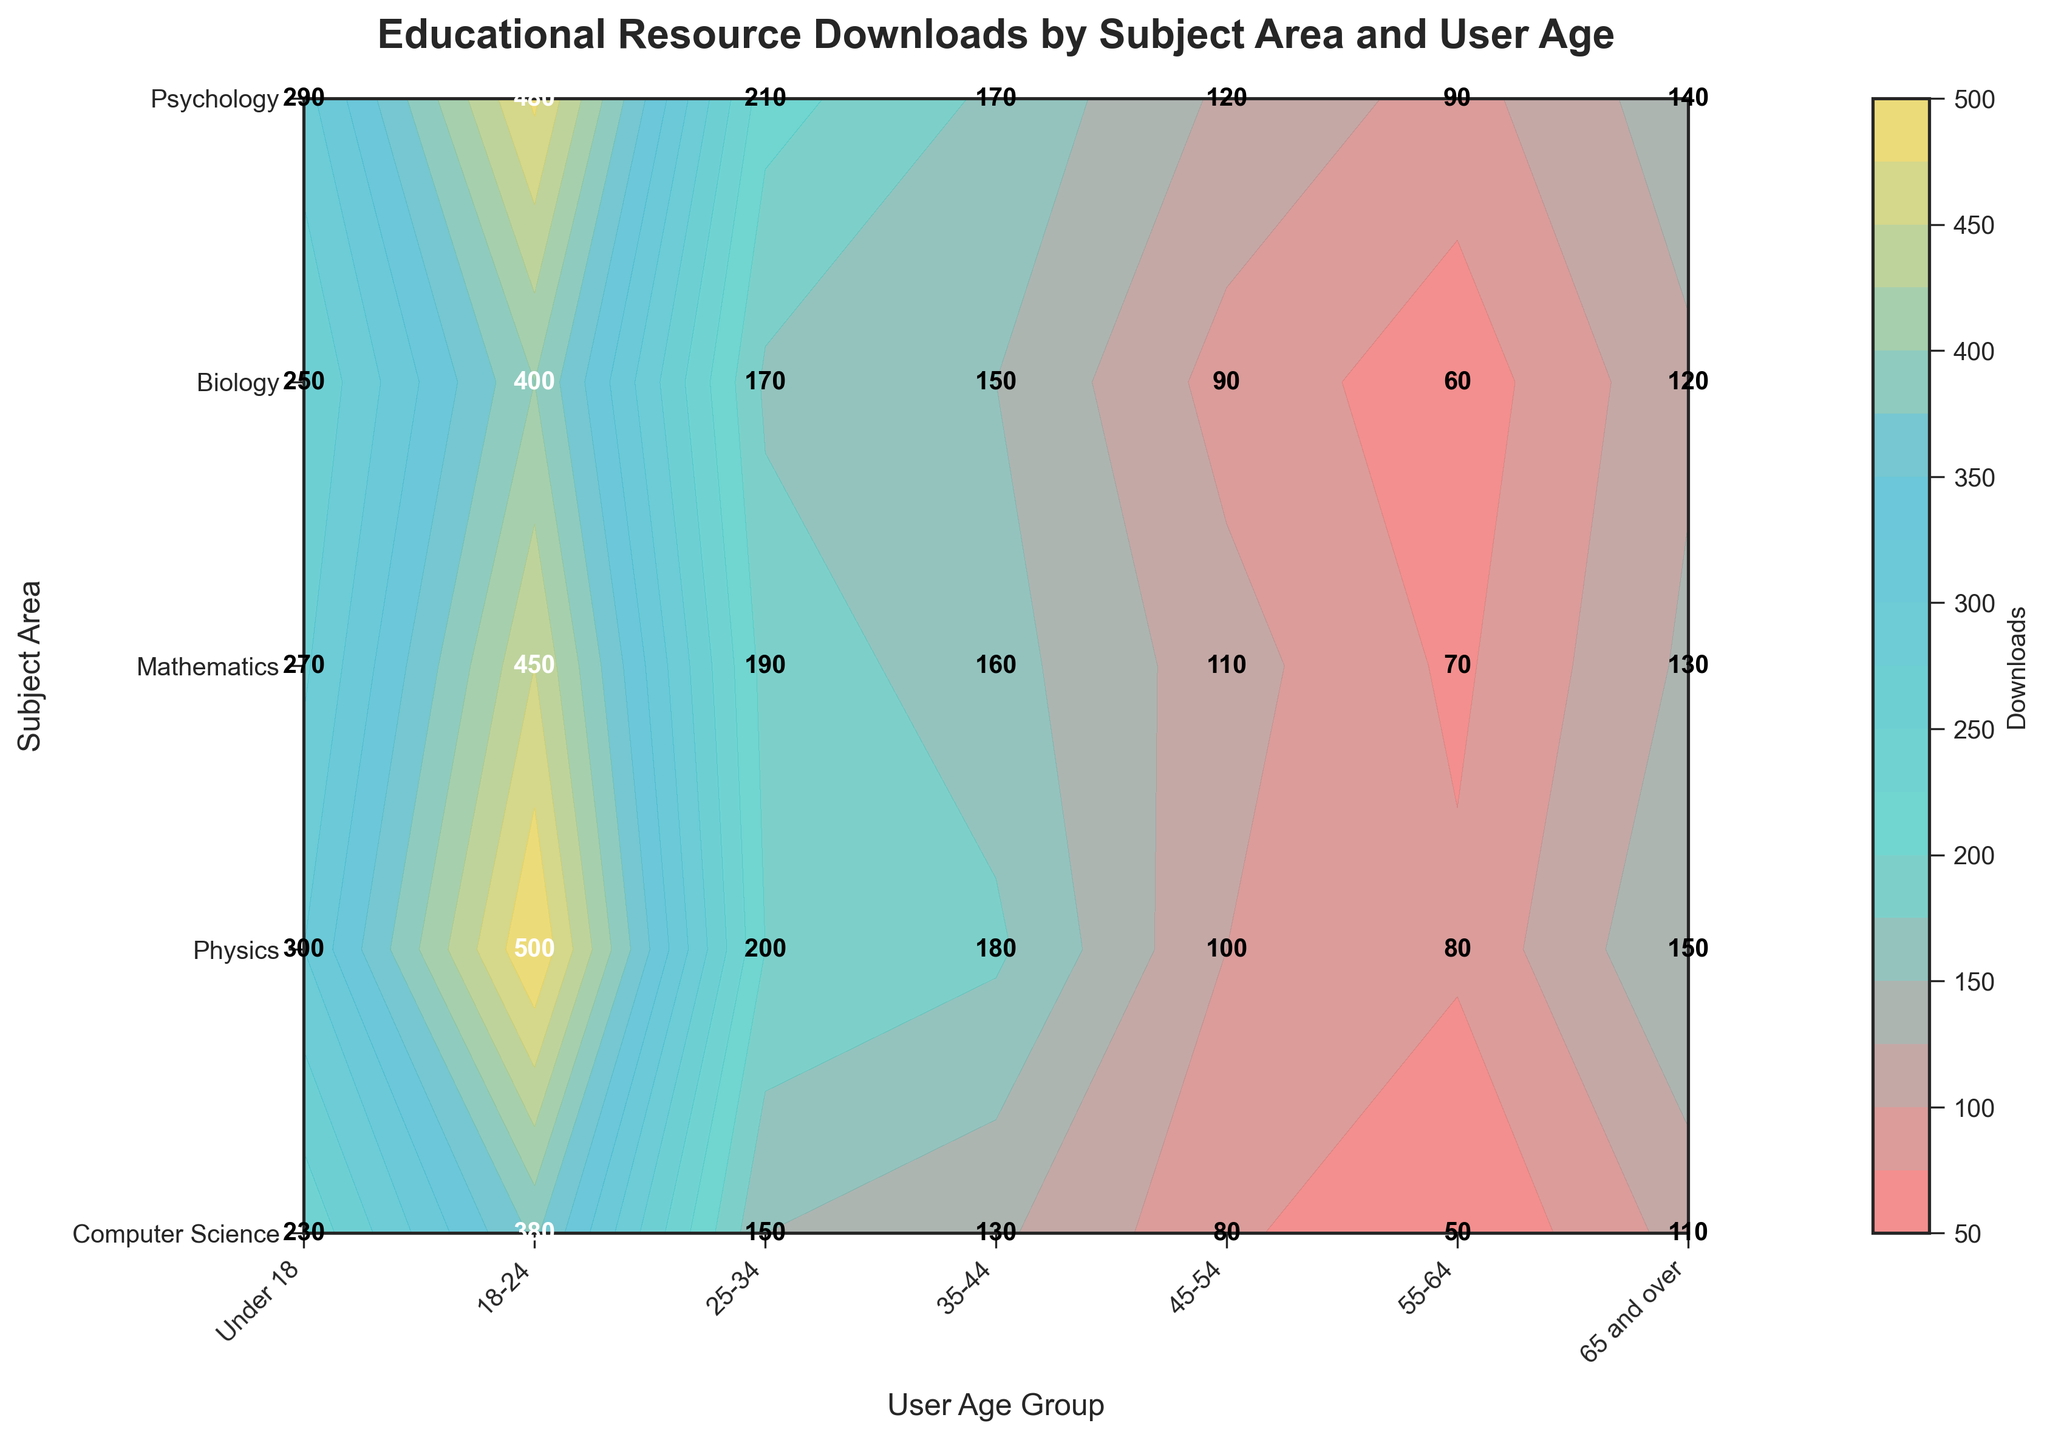What is the title of the plot? The title of the plot is centered at the top and reads "Educational Resource Downloads by Subject Area and User Age".
Answer: "Educational Resource Downloads by Subject Area and User Age" Which subject area shows the highest number of downloads for the age group 25-34? Identify the cell corresponding to the subject area and age group, then check the download numbers. The highest value in the 25-34 age group is found in the Psychology row.
Answer: Psychology What age group had the least downloads in Biology? Locate the Biology row and find the minimum value across the age groups. The lowest number is in the 65 and over age group.
Answer: 65 and over Which age group performed the most downloads regardless of subject area? Sum the downloads for each age group across all subject areas and compare the sums. The age group 25-34 has the highest total downloads among all age groups.
Answer: 25-34 How does the number of downloads for Computer Science in the 18-24 age group compare with those in the 55-64 age group? Find the values for Computer Science in the 18-24 and 55-64 age groups, then compare them. The 18-24 age group has 300 downloads, while the 55-64 age group has only 100.
Answer: 300 vs 100 What's the difference in the number of downloads between Mathematics for the age groups 18-24 and 45-54? Locate the values for Mathematics in the age groups 18-24 and 45-54, then subtract the smaller from the larger. The difference is 270 - 160 = 110.
Answer: 110 In which subject area do users aged under 18 download the fewest resources? Identify the under 18 age group column and find the subject with the lowest value. Biology has the fewest downloads in this age group with 110.
Answer: Biology What is the average number of downloads for Physics across all age groups? Sum the values for Physics across all age groups and divide by the number of groups. The average is (120 + 250 + 400 + 170 + 150 + 90 + 60) / 7 = 177.14.
Answer: 177.14 Which age group has more downloads in Mathematics than in Physics? Compare the values of Mathematics and Physics for each age group. The age groups under 18, 18-24, 25-34, 35-44, and 45-54 all have more downloads in Mathematics than in Physics.
Answer: Multiple age groups Do users aged 25-34 download more resources from Computer Science or Biology? Compare the values for 25-34 age group in both Computer Science and Biology. The downloads for Computer Science are 500 and for Biology are 380.
Answer: Computer Science 